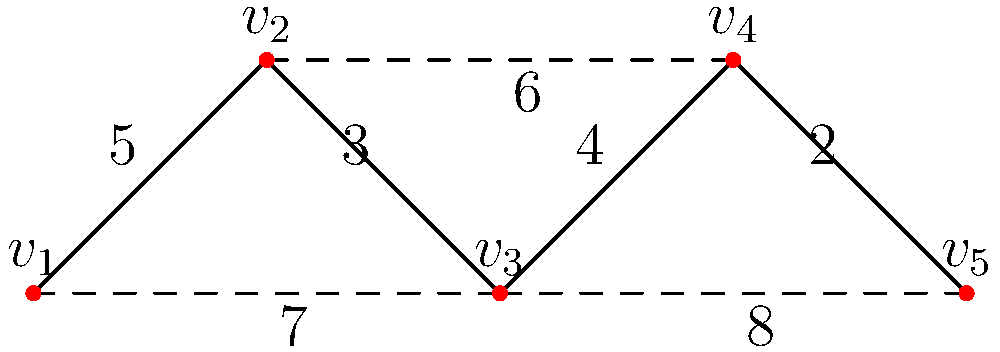In this network representing religious content sharing on social media, vertices represent influential accounts, and edge weights represent the strength of content sharing between accounts. What is the total strength of the minimum spanning tree that connects all influential accounts? To find the minimum spanning tree (MST) that connects all influential accounts with the minimum total strength, we can use Kruskal's algorithm:

1. Sort all edges by weight in ascending order:
   (v4-v5): 2
   (v2-v3): 3
   (v3-v4): 4
   (v1-v2): 5
   (v2-v4): 6
   (v1-v3): 7
   (v3-v5): 8

2. Start with an empty MST and add edges in order, skipping those that would create a cycle:
   - Add (v4-v5): 2
   - Add (v2-v3): 3
   - Add (v3-v4): 4
   - Add (v1-v2): 5

3. The MST is complete as it now includes all 5 vertices.

4. Calculate the total strength of the MST:
   $2 + 3 + 4 + 5 = 14$

Therefore, the total strength of the minimum spanning tree is 14.
Answer: 14 